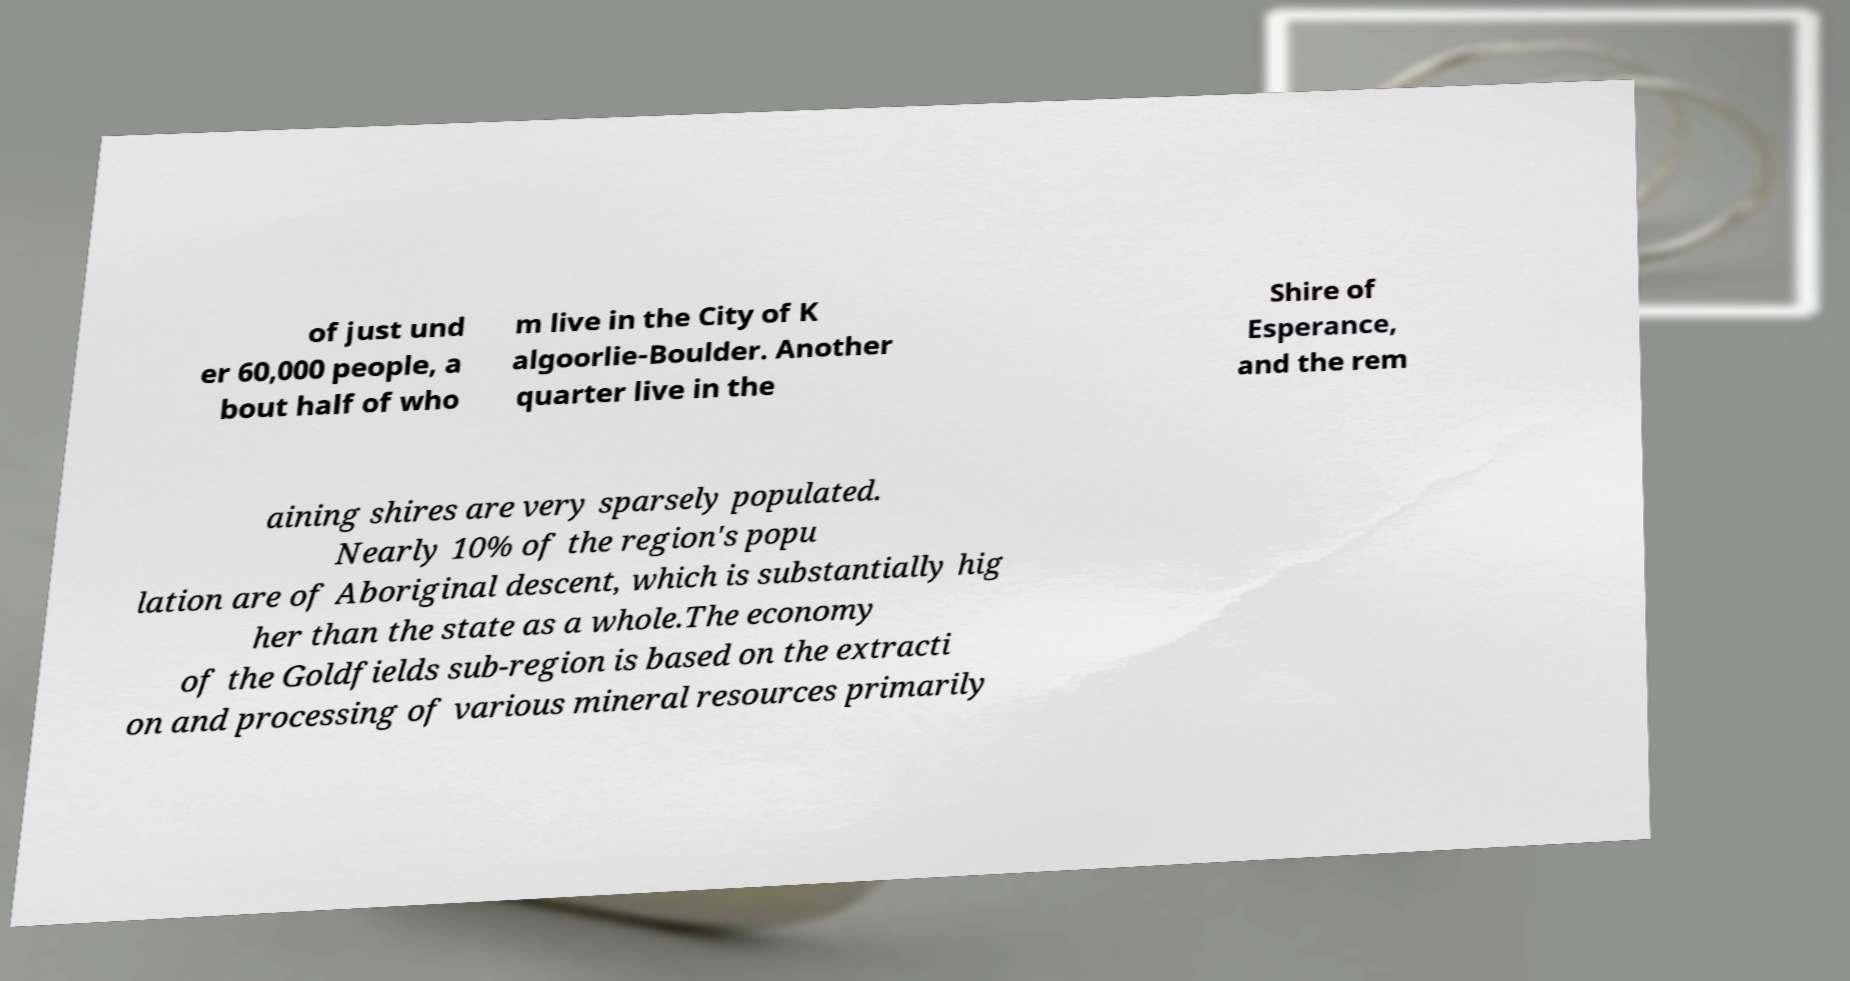Please identify and transcribe the text found in this image. of just und er 60,000 people, a bout half of who m live in the City of K algoorlie-Boulder. Another quarter live in the Shire of Esperance, and the rem aining shires are very sparsely populated. Nearly 10% of the region's popu lation are of Aboriginal descent, which is substantially hig her than the state as a whole.The economy of the Goldfields sub-region is based on the extracti on and processing of various mineral resources primarily 